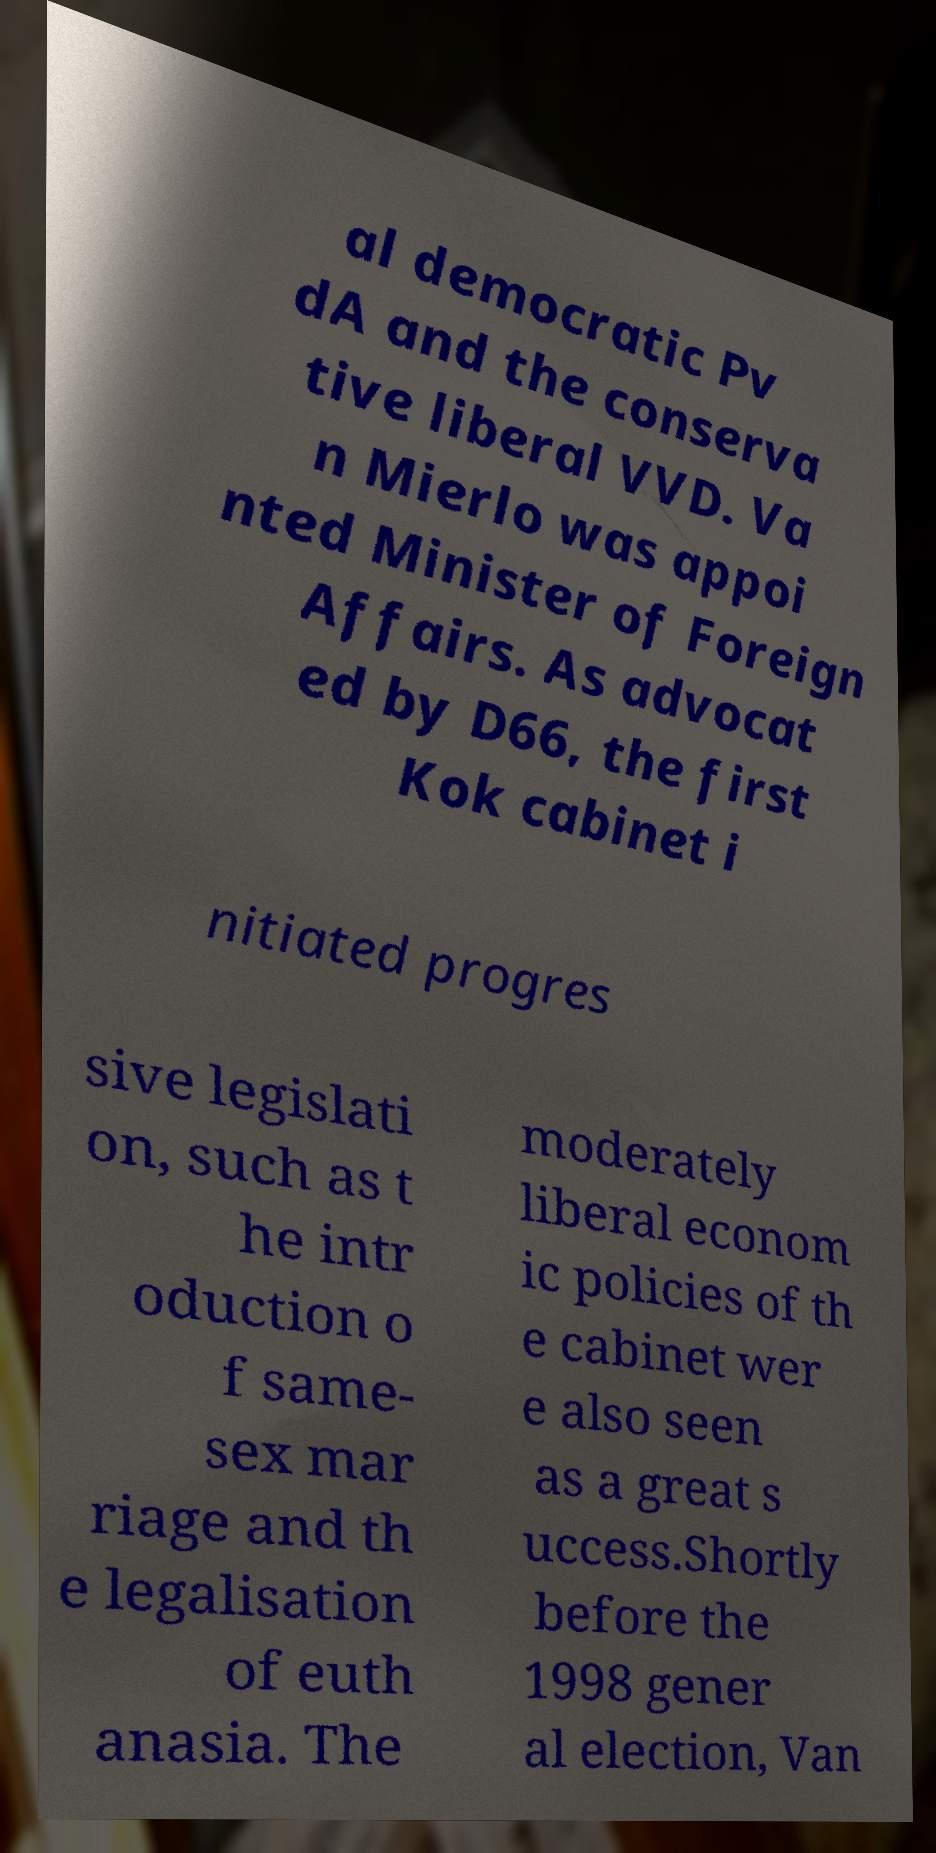Please identify and transcribe the text found in this image. al democratic Pv dA and the conserva tive liberal VVD. Va n Mierlo was appoi nted Minister of Foreign Affairs. As advocat ed by D66, the first Kok cabinet i nitiated progres sive legislati on, such as t he intr oduction o f same- sex mar riage and th e legalisation of euth anasia. The moderately liberal econom ic policies of th e cabinet wer e also seen as a great s uccess.Shortly before the 1998 gener al election, Van 